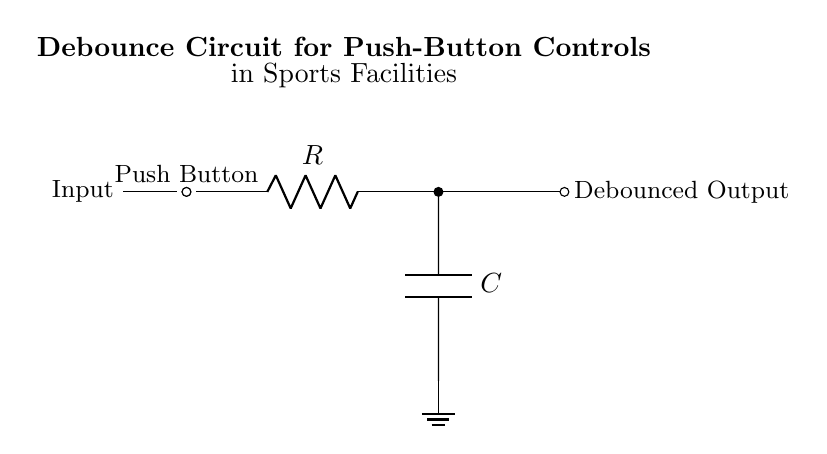What type of circuit is shown? The circuit is a debounce circuit utilizing a resistor and capacitor to eliminate noise from a push-button signal.
Answer: Debounce circuit What components are included in the circuit? The circuit comprises a push-button switch, a resistor (labeled R), and a capacitor (labeled C).
Answer: Push button, resistor, capacitor What is the purpose of the capacitor in this circuit? The capacitor serves to filter out rapid oscillations caused by the mechanical bouncing of the push button, smoothing out the transitions to provide a clean signal.
Answer: To filter noise What is the function of the resistor in the circuit? The resistor limits the current flowing into the capacitor, which helps control the charging time and subsequently influences the debounce time.
Answer: To limit current What happens if the resistance is increased? Increasing the resistance would result in a longer charging time for the capacitor, which would increase the debounce period and provide more time for bouncing to settle.
Answer: Debounce period increases How does the capacitor affect the output when the button is pressed? When the button is pressed, the capacitor begins to charge through the resistor, creating a delay in the output signal change, which prevents false triggering from bouncing.
Answer: Delays output signal What is the expected result on the output when the button is pressed and released quickly? The output should remain stable and not reflect the rapid presses due to the actions of the resistor and capacitor working together to debounce the signal.
Answer: Stable output 